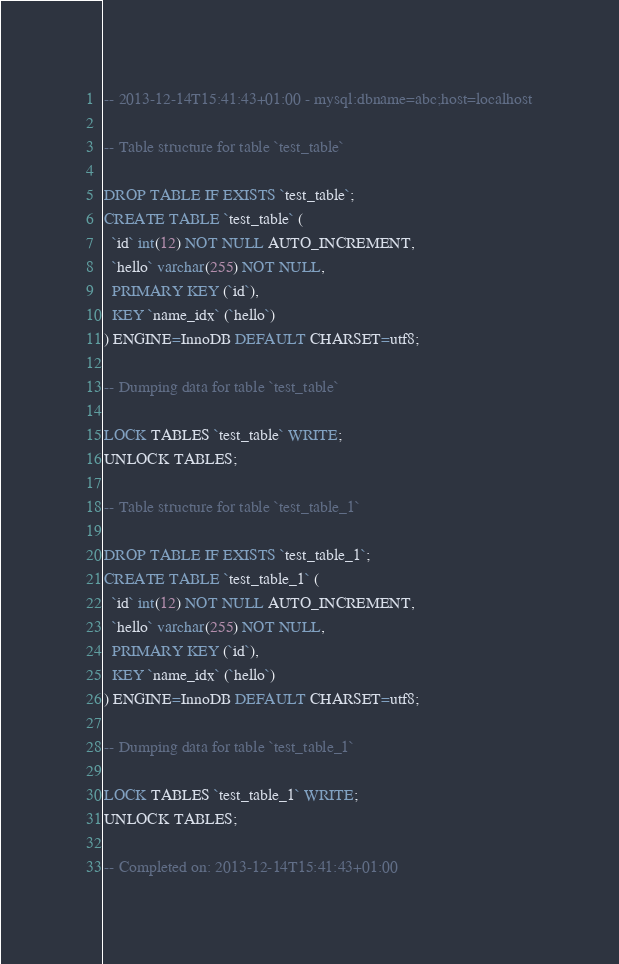<code> <loc_0><loc_0><loc_500><loc_500><_SQL_>-- 2013-12-14T15:41:43+01:00 - mysql:dbname=abc;host=localhost

-- Table structure for table `test_table`

DROP TABLE IF EXISTS `test_table`;
CREATE TABLE `test_table` (
  `id` int(12) NOT NULL AUTO_INCREMENT,
  `hello` varchar(255) NOT NULL,
  PRIMARY KEY (`id`),
  KEY `name_idx` (`hello`)
) ENGINE=InnoDB DEFAULT CHARSET=utf8;

-- Dumping data for table `test_table`

LOCK TABLES `test_table` WRITE;
UNLOCK TABLES;

-- Table structure for table `test_table_1`

DROP TABLE IF EXISTS `test_table_1`;
CREATE TABLE `test_table_1` (
  `id` int(12) NOT NULL AUTO_INCREMENT,
  `hello` varchar(255) NOT NULL,
  PRIMARY KEY (`id`),
  KEY `name_idx` (`hello`)
) ENGINE=InnoDB DEFAULT CHARSET=utf8;

-- Dumping data for table `test_table_1`

LOCK TABLES `test_table_1` WRITE;
UNLOCK TABLES;

-- Completed on: 2013-12-14T15:41:43+01:00
</code> 